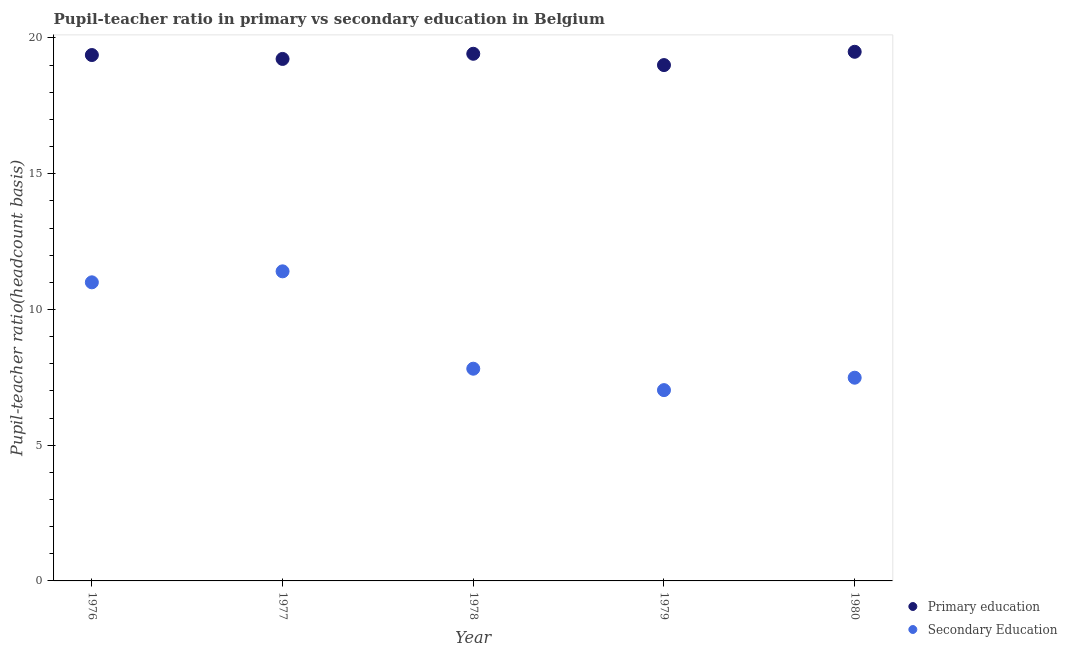How many different coloured dotlines are there?
Make the answer very short. 2. What is the pupil-teacher ratio in primary education in 1979?
Your answer should be very brief. 19. Across all years, what is the maximum pupil teacher ratio on secondary education?
Make the answer very short. 11.4. Across all years, what is the minimum pupil teacher ratio on secondary education?
Provide a short and direct response. 7.03. In which year was the pupil teacher ratio on secondary education minimum?
Provide a succinct answer. 1979. What is the total pupil-teacher ratio in primary education in the graph?
Keep it short and to the point. 96.51. What is the difference between the pupil teacher ratio on secondary education in 1976 and that in 1979?
Give a very brief answer. 3.97. What is the difference between the pupil teacher ratio on secondary education in 1978 and the pupil-teacher ratio in primary education in 1977?
Make the answer very short. -11.41. What is the average pupil-teacher ratio in primary education per year?
Ensure brevity in your answer.  19.3. In the year 1977, what is the difference between the pupil-teacher ratio in primary education and pupil teacher ratio on secondary education?
Provide a succinct answer. 7.82. What is the ratio of the pupil teacher ratio on secondary education in 1976 to that in 1978?
Offer a terse response. 1.41. What is the difference between the highest and the second highest pupil-teacher ratio in primary education?
Offer a terse response. 0.07. What is the difference between the highest and the lowest pupil-teacher ratio in primary education?
Keep it short and to the point. 0.49. Is the pupil-teacher ratio in primary education strictly greater than the pupil teacher ratio on secondary education over the years?
Ensure brevity in your answer.  Yes. Does the graph contain any zero values?
Provide a succinct answer. No. Does the graph contain grids?
Your answer should be compact. No. Where does the legend appear in the graph?
Make the answer very short. Bottom right. How many legend labels are there?
Provide a short and direct response. 2. What is the title of the graph?
Make the answer very short. Pupil-teacher ratio in primary vs secondary education in Belgium. Does "Highest 10% of population" appear as one of the legend labels in the graph?
Keep it short and to the point. No. What is the label or title of the Y-axis?
Your answer should be compact. Pupil-teacher ratio(headcount basis). What is the Pupil-teacher ratio(headcount basis) of Primary education in 1976?
Offer a very short reply. 19.37. What is the Pupil-teacher ratio(headcount basis) in Secondary Education in 1976?
Your response must be concise. 11. What is the Pupil-teacher ratio(headcount basis) of Primary education in 1977?
Provide a succinct answer. 19.23. What is the Pupil-teacher ratio(headcount basis) of Secondary Education in 1977?
Make the answer very short. 11.4. What is the Pupil-teacher ratio(headcount basis) in Primary education in 1978?
Make the answer very short. 19.42. What is the Pupil-teacher ratio(headcount basis) in Secondary Education in 1978?
Offer a terse response. 7.82. What is the Pupil-teacher ratio(headcount basis) of Primary education in 1979?
Give a very brief answer. 19. What is the Pupil-teacher ratio(headcount basis) in Secondary Education in 1979?
Your answer should be compact. 7.03. What is the Pupil-teacher ratio(headcount basis) of Primary education in 1980?
Your answer should be compact. 19.49. What is the Pupil-teacher ratio(headcount basis) in Secondary Education in 1980?
Your response must be concise. 7.49. Across all years, what is the maximum Pupil-teacher ratio(headcount basis) in Primary education?
Give a very brief answer. 19.49. Across all years, what is the maximum Pupil-teacher ratio(headcount basis) in Secondary Education?
Give a very brief answer. 11.4. Across all years, what is the minimum Pupil-teacher ratio(headcount basis) in Primary education?
Provide a succinct answer. 19. Across all years, what is the minimum Pupil-teacher ratio(headcount basis) in Secondary Education?
Your answer should be very brief. 7.03. What is the total Pupil-teacher ratio(headcount basis) in Primary education in the graph?
Offer a very short reply. 96.51. What is the total Pupil-teacher ratio(headcount basis) of Secondary Education in the graph?
Offer a terse response. 44.73. What is the difference between the Pupil-teacher ratio(headcount basis) in Primary education in 1976 and that in 1977?
Your answer should be very brief. 0.14. What is the difference between the Pupil-teacher ratio(headcount basis) of Secondary Education in 1976 and that in 1977?
Make the answer very short. -0.4. What is the difference between the Pupil-teacher ratio(headcount basis) in Primary education in 1976 and that in 1978?
Your answer should be very brief. -0.05. What is the difference between the Pupil-teacher ratio(headcount basis) in Secondary Education in 1976 and that in 1978?
Provide a succinct answer. 3.18. What is the difference between the Pupil-teacher ratio(headcount basis) in Primary education in 1976 and that in 1979?
Make the answer very short. 0.37. What is the difference between the Pupil-teacher ratio(headcount basis) of Secondary Education in 1976 and that in 1979?
Ensure brevity in your answer.  3.97. What is the difference between the Pupil-teacher ratio(headcount basis) of Primary education in 1976 and that in 1980?
Provide a short and direct response. -0.12. What is the difference between the Pupil-teacher ratio(headcount basis) in Secondary Education in 1976 and that in 1980?
Ensure brevity in your answer.  3.51. What is the difference between the Pupil-teacher ratio(headcount basis) of Primary education in 1977 and that in 1978?
Offer a very short reply. -0.19. What is the difference between the Pupil-teacher ratio(headcount basis) of Secondary Education in 1977 and that in 1978?
Offer a very short reply. 3.59. What is the difference between the Pupil-teacher ratio(headcount basis) in Primary education in 1977 and that in 1979?
Your response must be concise. 0.23. What is the difference between the Pupil-teacher ratio(headcount basis) in Secondary Education in 1977 and that in 1979?
Keep it short and to the point. 4.38. What is the difference between the Pupil-teacher ratio(headcount basis) in Primary education in 1977 and that in 1980?
Provide a succinct answer. -0.26. What is the difference between the Pupil-teacher ratio(headcount basis) in Secondary Education in 1977 and that in 1980?
Provide a short and direct response. 3.92. What is the difference between the Pupil-teacher ratio(headcount basis) of Primary education in 1978 and that in 1979?
Make the answer very short. 0.42. What is the difference between the Pupil-teacher ratio(headcount basis) of Secondary Education in 1978 and that in 1979?
Your answer should be very brief. 0.79. What is the difference between the Pupil-teacher ratio(headcount basis) in Primary education in 1978 and that in 1980?
Your answer should be very brief. -0.07. What is the difference between the Pupil-teacher ratio(headcount basis) in Secondary Education in 1978 and that in 1980?
Make the answer very short. 0.33. What is the difference between the Pupil-teacher ratio(headcount basis) of Primary education in 1979 and that in 1980?
Offer a very short reply. -0.49. What is the difference between the Pupil-teacher ratio(headcount basis) of Secondary Education in 1979 and that in 1980?
Give a very brief answer. -0.46. What is the difference between the Pupil-teacher ratio(headcount basis) of Primary education in 1976 and the Pupil-teacher ratio(headcount basis) of Secondary Education in 1977?
Ensure brevity in your answer.  7.97. What is the difference between the Pupil-teacher ratio(headcount basis) of Primary education in 1976 and the Pupil-teacher ratio(headcount basis) of Secondary Education in 1978?
Keep it short and to the point. 11.55. What is the difference between the Pupil-teacher ratio(headcount basis) in Primary education in 1976 and the Pupil-teacher ratio(headcount basis) in Secondary Education in 1979?
Your answer should be compact. 12.34. What is the difference between the Pupil-teacher ratio(headcount basis) in Primary education in 1976 and the Pupil-teacher ratio(headcount basis) in Secondary Education in 1980?
Offer a terse response. 11.89. What is the difference between the Pupil-teacher ratio(headcount basis) of Primary education in 1977 and the Pupil-teacher ratio(headcount basis) of Secondary Education in 1978?
Give a very brief answer. 11.41. What is the difference between the Pupil-teacher ratio(headcount basis) in Primary education in 1977 and the Pupil-teacher ratio(headcount basis) in Secondary Education in 1979?
Make the answer very short. 12.2. What is the difference between the Pupil-teacher ratio(headcount basis) of Primary education in 1977 and the Pupil-teacher ratio(headcount basis) of Secondary Education in 1980?
Provide a succinct answer. 11.74. What is the difference between the Pupil-teacher ratio(headcount basis) in Primary education in 1978 and the Pupil-teacher ratio(headcount basis) in Secondary Education in 1979?
Your response must be concise. 12.39. What is the difference between the Pupil-teacher ratio(headcount basis) in Primary education in 1978 and the Pupil-teacher ratio(headcount basis) in Secondary Education in 1980?
Ensure brevity in your answer.  11.93. What is the difference between the Pupil-teacher ratio(headcount basis) of Primary education in 1979 and the Pupil-teacher ratio(headcount basis) of Secondary Education in 1980?
Offer a very short reply. 11.52. What is the average Pupil-teacher ratio(headcount basis) in Primary education per year?
Your answer should be compact. 19.3. What is the average Pupil-teacher ratio(headcount basis) in Secondary Education per year?
Provide a succinct answer. 8.95. In the year 1976, what is the difference between the Pupil-teacher ratio(headcount basis) in Primary education and Pupil-teacher ratio(headcount basis) in Secondary Education?
Provide a succinct answer. 8.37. In the year 1977, what is the difference between the Pupil-teacher ratio(headcount basis) of Primary education and Pupil-teacher ratio(headcount basis) of Secondary Education?
Your answer should be compact. 7.82. In the year 1978, what is the difference between the Pupil-teacher ratio(headcount basis) in Primary education and Pupil-teacher ratio(headcount basis) in Secondary Education?
Your answer should be compact. 11.6. In the year 1979, what is the difference between the Pupil-teacher ratio(headcount basis) in Primary education and Pupil-teacher ratio(headcount basis) in Secondary Education?
Make the answer very short. 11.97. In the year 1980, what is the difference between the Pupil-teacher ratio(headcount basis) in Primary education and Pupil-teacher ratio(headcount basis) in Secondary Education?
Ensure brevity in your answer.  12.01. What is the ratio of the Pupil-teacher ratio(headcount basis) in Primary education in 1976 to that in 1977?
Keep it short and to the point. 1.01. What is the ratio of the Pupil-teacher ratio(headcount basis) of Secondary Education in 1976 to that in 1977?
Make the answer very short. 0.96. What is the ratio of the Pupil-teacher ratio(headcount basis) in Primary education in 1976 to that in 1978?
Your answer should be very brief. 1. What is the ratio of the Pupil-teacher ratio(headcount basis) in Secondary Education in 1976 to that in 1978?
Your answer should be very brief. 1.41. What is the ratio of the Pupil-teacher ratio(headcount basis) in Primary education in 1976 to that in 1979?
Provide a short and direct response. 1.02. What is the ratio of the Pupil-teacher ratio(headcount basis) of Secondary Education in 1976 to that in 1979?
Offer a terse response. 1.56. What is the ratio of the Pupil-teacher ratio(headcount basis) of Secondary Education in 1976 to that in 1980?
Offer a terse response. 1.47. What is the ratio of the Pupil-teacher ratio(headcount basis) of Primary education in 1977 to that in 1978?
Your response must be concise. 0.99. What is the ratio of the Pupil-teacher ratio(headcount basis) in Secondary Education in 1977 to that in 1978?
Your answer should be compact. 1.46. What is the ratio of the Pupil-teacher ratio(headcount basis) in Primary education in 1977 to that in 1979?
Provide a short and direct response. 1.01. What is the ratio of the Pupil-teacher ratio(headcount basis) in Secondary Education in 1977 to that in 1979?
Your answer should be very brief. 1.62. What is the ratio of the Pupil-teacher ratio(headcount basis) of Primary education in 1977 to that in 1980?
Offer a terse response. 0.99. What is the ratio of the Pupil-teacher ratio(headcount basis) of Secondary Education in 1977 to that in 1980?
Your answer should be compact. 1.52. What is the ratio of the Pupil-teacher ratio(headcount basis) in Primary education in 1978 to that in 1979?
Give a very brief answer. 1.02. What is the ratio of the Pupil-teacher ratio(headcount basis) in Secondary Education in 1978 to that in 1979?
Keep it short and to the point. 1.11. What is the ratio of the Pupil-teacher ratio(headcount basis) of Primary education in 1978 to that in 1980?
Your answer should be very brief. 1. What is the ratio of the Pupil-teacher ratio(headcount basis) of Secondary Education in 1978 to that in 1980?
Offer a terse response. 1.04. What is the ratio of the Pupil-teacher ratio(headcount basis) of Primary education in 1979 to that in 1980?
Your response must be concise. 0.97. What is the ratio of the Pupil-teacher ratio(headcount basis) in Secondary Education in 1979 to that in 1980?
Ensure brevity in your answer.  0.94. What is the difference between the highest and the second highest Pupil-teacher ratio(headcount basis) in Primary education?
Make the answer very short. 0.07. What is the difference between the highest and the second highest Pupil-teacher ratio(headcount basis) of Secondary Education?
Your answer should be compact. 0.4. What is the difference between the highest and the lowest Pupil-teacher ratio(headcount basis) in Primary education?
Ensure brevity in your answer.  0.49. What is the difference between the highest and the lowest Pupil-teacher ratio(headcount basis) of Secondary Education?
Make the answer very short. 4.38. 